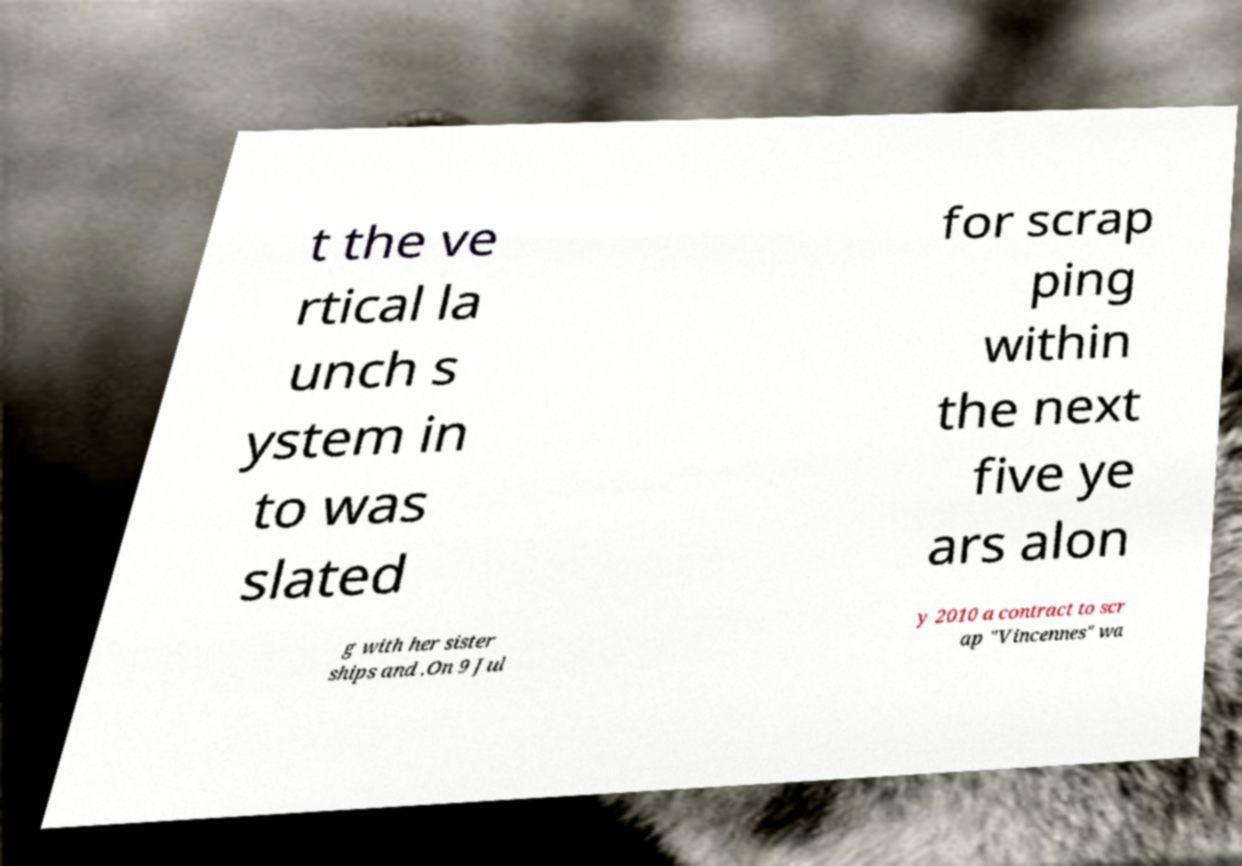Can you read and provide the text displayed in the image?This photo seems to have some interesting text. Can you extract and type it out for me? t the ve rtical la unch s ystem in to was slated for scrap ping within the next five ye ars alon g with her sister ships and .On 9 Jul y 2010 a contract to scr ap "Vincennes" wa 